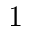<formula> <loc_0><loc_0><loc_500><loc_500>1</formula> 